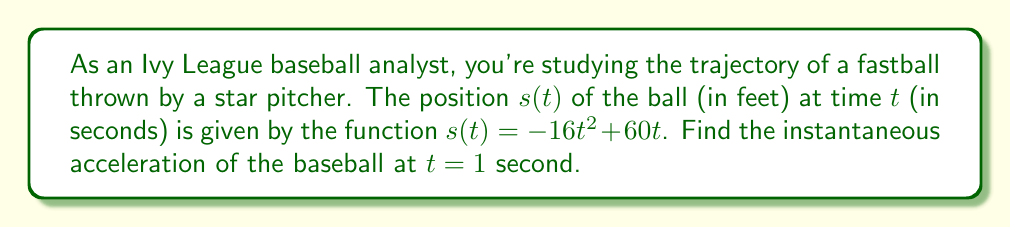Solve this math problem. To find the instantaneous acceleration, we need to take the second derivative of the position function.

Step 1: Find the velocity function (first derivative)
The velocity function $v(t)$ is the first derivative of the position function:
$$v(t) = \frac{d}{dt}s(t) = \frac{d}{dt}(-16t^2 + 60t) = -32t + 60$$

Step 2: Find the acceleration function (second derivative)
The acceleration function $a(t)$ is the derivative of the velocity function:
$$a(t) = \frac{d}{dt}v(t) = \frac{d}{dt}(-32t + 60) = -32$$

Step 3: Evaluate the acceleration function at $t = 1$
Since the acceleration function is constant, we don't need to substitute $t = 1$. The acceleration is always $-32$ ft/s².

Note: The negative sign indicates that the ball is decelerating, which is expected due to gravity and air resistance.
Answer: $-32$ ft/s² 